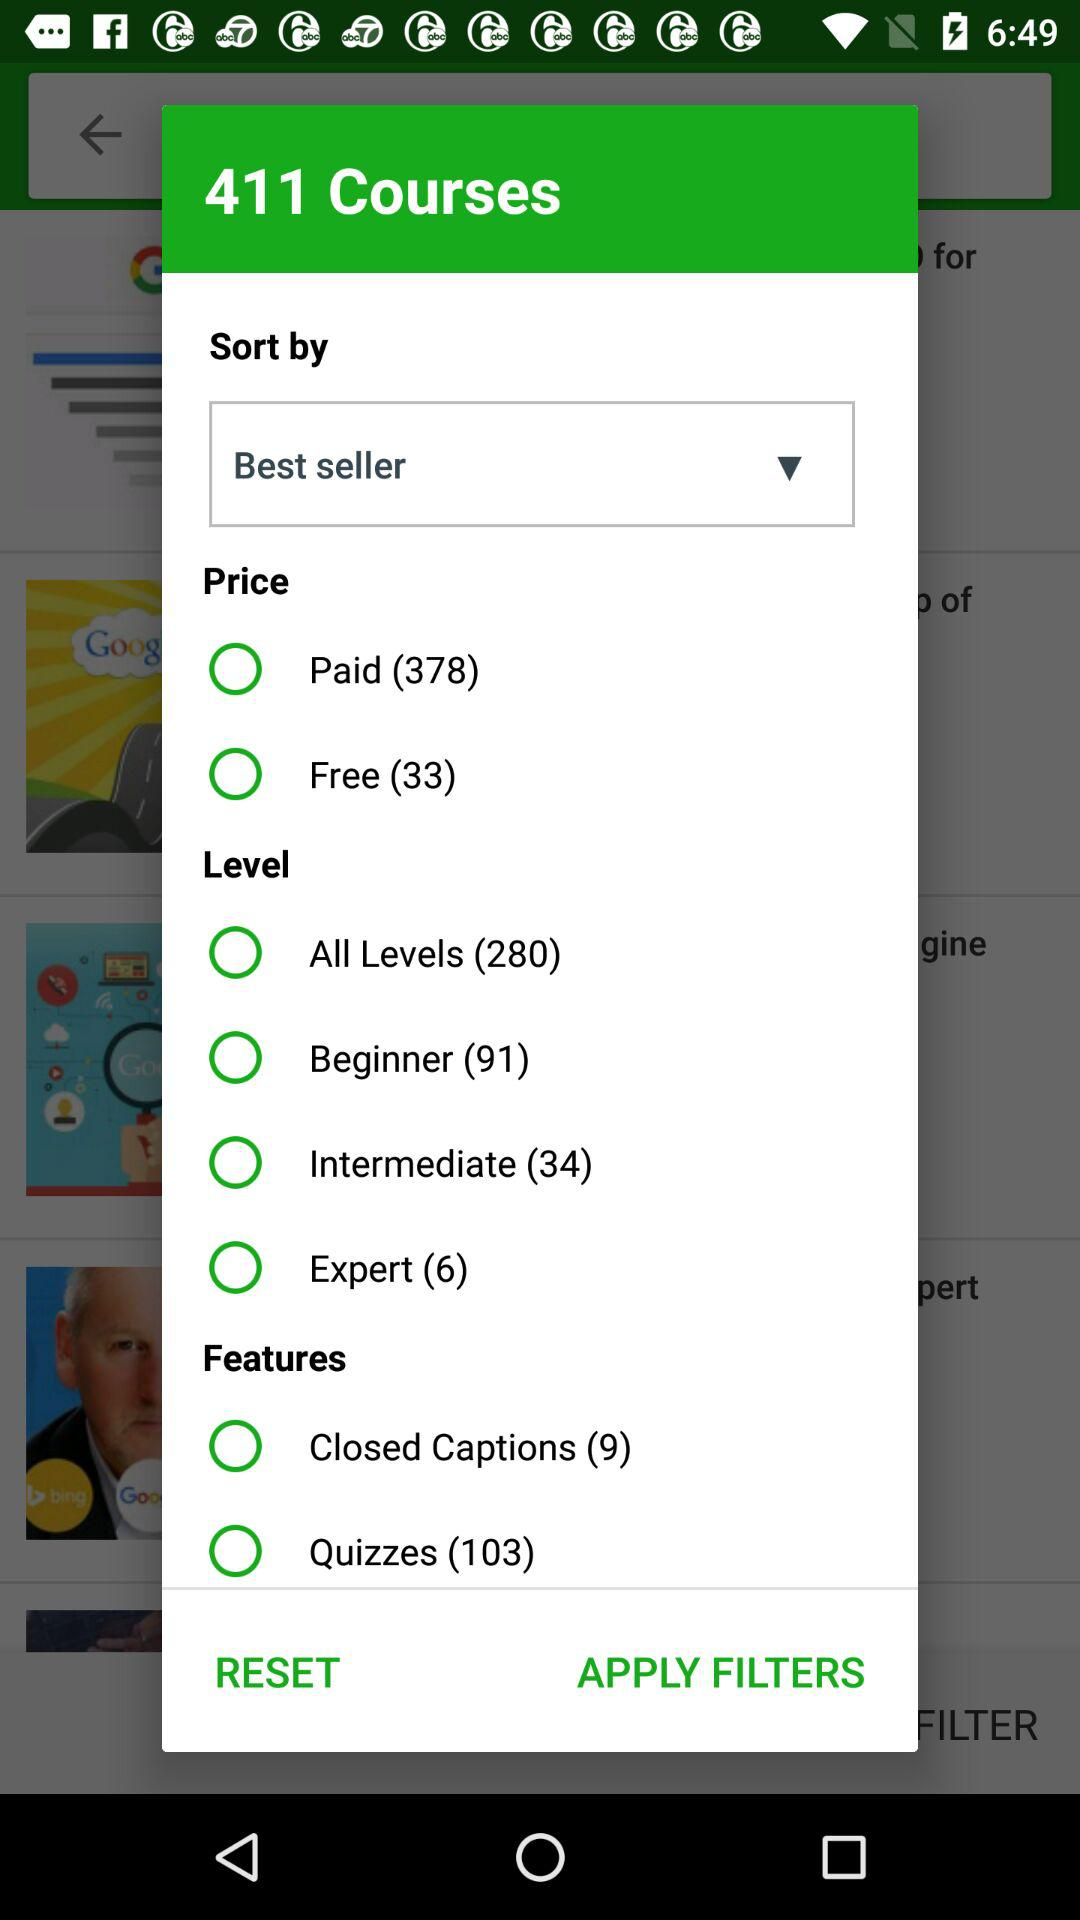How many more paid courses are there than free courses?
Answer the question using a single word or phrase. 345 